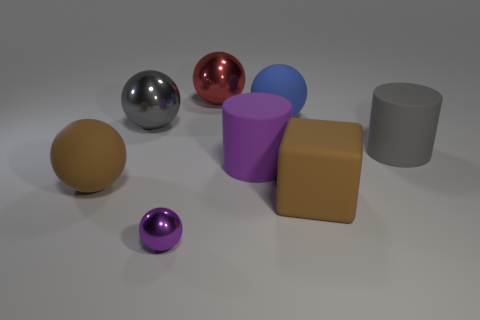There is a rubber thing that is the same color as the cube; what is its shape?
Ensure brevity in your answer.  Sphere. How many matte things are either tiny balls or purple cylinders?
Make the answer very short. 1. Is the small ball the same color as the big rubber cube?
Your answer should be compact. No. What number of things are tiny green matte spheres or big brown things right of the purple ball?
Your answer should be compact. 1. Does the blue matte thing that is behind the purple cylinder have the same size as the big gray cylinder?
Make the answer very short. Yes. How many other objects are the same shape as the gray metallic object?
Offer a terse response. 4. How many gray objects are either large cylinders or matte spheres?
Your answer should be very brief. 1. There is a big thing that is to the right of the big brown cube; is its color the same as the large cube?
Provide a succinct answer. No. What shape is the gray object that is made of the same material as the big blue object?
Offer a terse response. Cylinder. There is a object that is to the left of the purple metal thing and in front of the purple matte object; what color is it?
Ensure brevity in your answer.  Brown. 